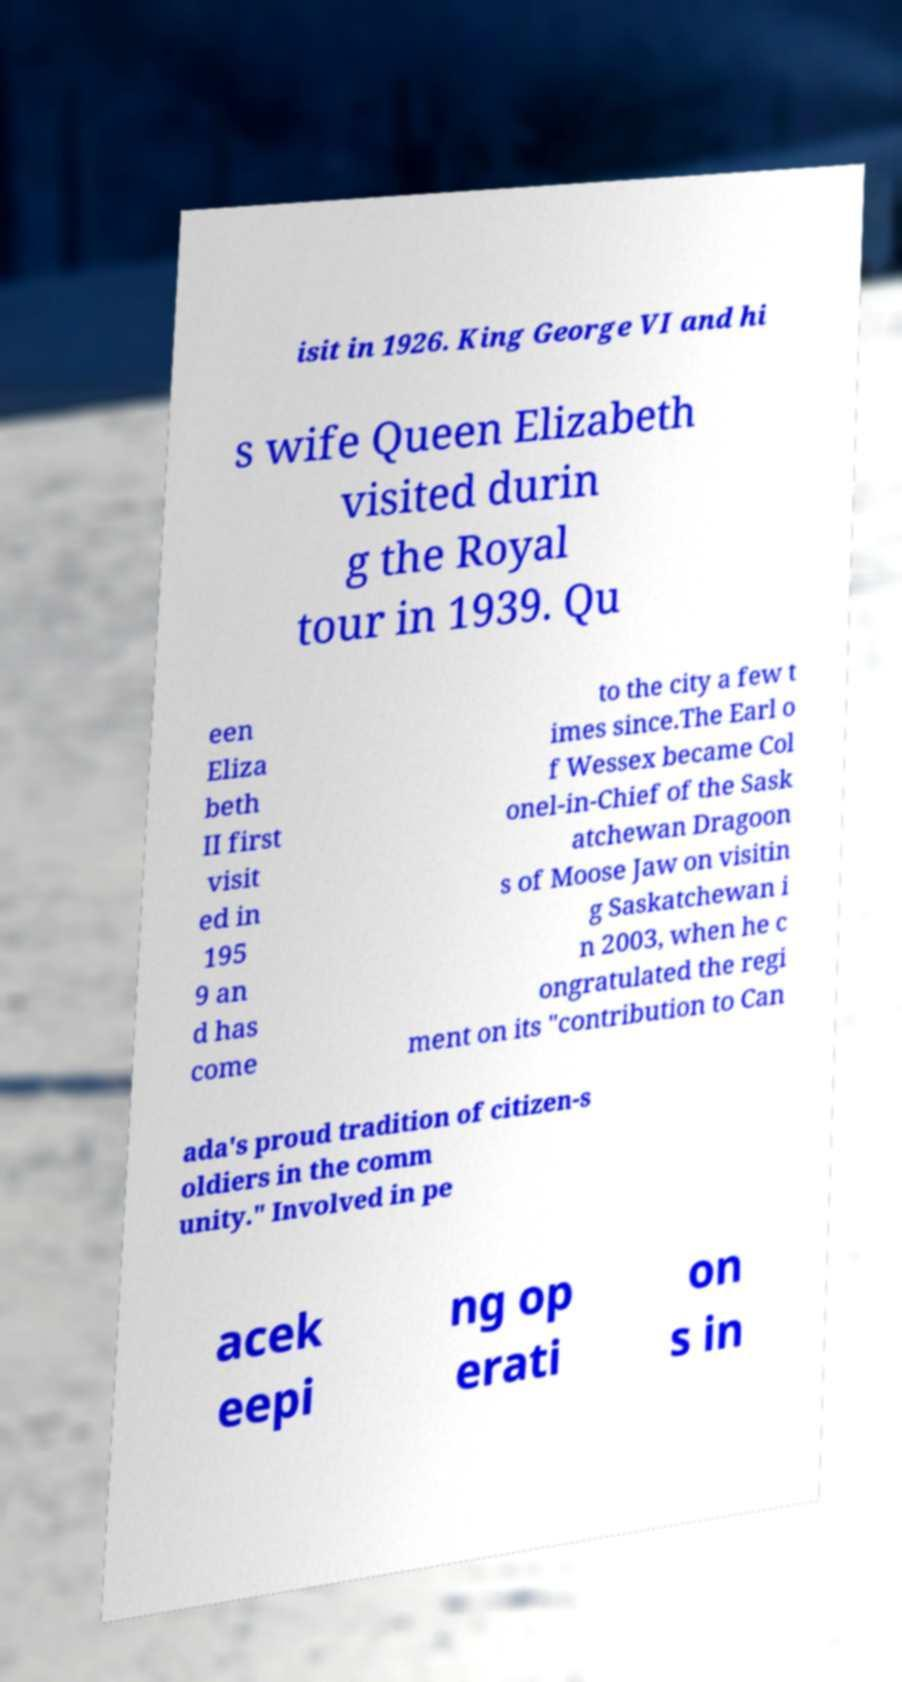For documentation purposes, I need the text within this image transcribed. Could you provide that? isit in 1926. King George VI and hi s wife Queen Elizabeth visited durin g the Royal tour in 1939. Qu een Eliza beth II first visit ed in 195 9 an d has come to the city a few t imes since.The Earl o f Wessex became Col onel-in-Chief of the Sask atchewan Dragoon s of Moose Jaw on visitin g Saskatchewan i n 2003, when he c ongratulated the regi ment on its "contribution to Can ada's proud tradition of citizen-s oldiers in the comm unity." Involved in pe acek eepi ng op erati on s in 